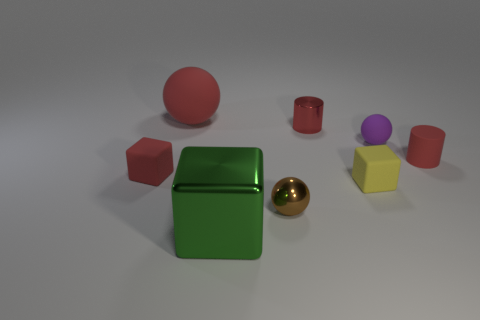Subtract all red matte blocks. How many blocks are left? 2 Subtract 1 blocks. How many blocks are left? 2 Add 2 small red matte things. How many objects exist? 10 Subtract all cylinders. How many objects are left? 6 Add 3 brown balls. How many brown balls are left? 4 Add 6 big red matte cylinders. How many big red matte cylinders exist? 6 Subtract 0 yellow spheres. How many objects are left? 8 Subtract all cyan balls. Subtract all brown cubes. How many balls are left? 3 Subtract all big yellow metallic objects. Subtract all big objects. How many objects are left? 6 